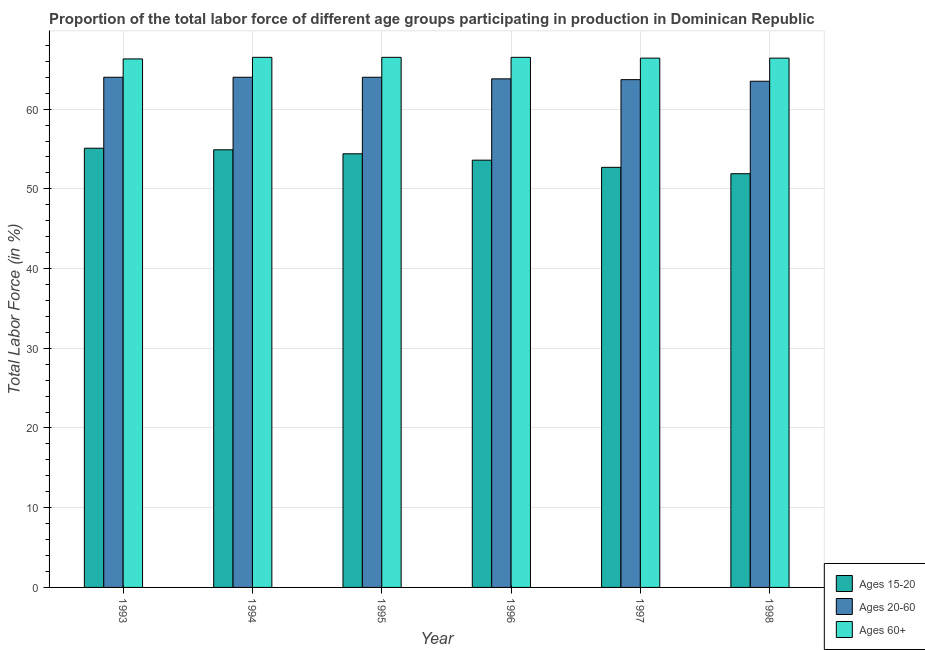How many different coloured bars are there?
Provide a succinct answer. 3. Are the number of bars on each tick of the X-axis equal?
Your response must be concise. Yes. How many bars are there on the 4th tick from the left?
Keep it short and to the point. 3. How many bars are there on the 6th tick from the right?
Make the answer very short. 3. In how many cases, is the number of bars for a given year not equal to the number of legend labels?
Provide a short and direct response. 0. What is the percentage of labor force above age 60 in 1996?
Your answer should be very brief. 66.5. Across all years, what is the maximum percentage of labor force within the age group 20-60?
Your answer should be compact. 64. Across all years, what is the minimum percentage of labor force within the age group 20-60?
Your response must be concise. 63.5. In which year was the percentage of labor force above age 60 maximum?
Your response must be concise. 1994. In which year was the percentage of labor force within the age group 20-60 minimum?
Make the answer very short. 1998. What is the total percentage of labor force within the age group 20-60 in the graph?
Make the answer very short. 383. What is the difference between the percentage of labor force within the age group 15-20 in 1995 and that in 1996?
Your answer should be compact. 0.8. What is the difference between the percentage of labor force within the age group 20-60 in 1998 and the percentage of labor force above age 60 in 1994?
Offer a very short reply. -0.5. What is the average percentage of labor force above age 60 per year?
Your answer should be compact. 66.43. In the year 1996, what is the difference between the percentage of labor force within the age group 15-20 and percentage of labor force above age 60?
Your answer should be very brief. 0. What is the ratio of the percentage of labor force above age 60 in 1994 to that in 1998?
Provide a succinct answer. 1. Is the percentage of labor force within the age group 20-60 in 1996 less than that in 1998?
Offer a terse response. No. What is the difference between the highest and the second highest percentage of labor force within the age group 20-60?
Ensure brevity in your answer.  0. What does the 1st bar from the left in 1994 represents?
Provide a succinct answer. Ages 15-20. What does the 3rd bar from the right in 1994 represents?
Ensure brevity in your answer.  Ages 15-20. Is it the case that in every year, the sum of the percentage of labor force within the age group 15-20 and percentage of labor force within the age group 20-60 is greater than the percentage of labor force above age 60?
Make the answer very short. Yes. Are all the bars in the graph horizontal?
Make the answer very short. No. What is the difference between two consecutive major ticks on the Y-axis?
Offer a terse response. 10. Are the values on the major ticks of Y-axis written in scientific E-notation?
Give a very brief answer. No. Does the graph contain any zero values?
Provide a short and direct response. No. How are the legend labels stacked?
Provide a succinct answer. Vertical. What is the title of the graph?
Provide a short and direct response. Proportion of the total labor force of different age groups participating in production in Dominican Republic. Does "Tertiary education" appear as one of the legend labels in the graph?
Provide a short and direct response. No. What is the Total Labor Force (in %) of Ages 15-20 in 1993?
Your response must be concise. 55.1. What is the Total Labor Force (in %) of Ages 60+ in 1993?
Your answer should be very brief. 66.3. What is the Total Labor Force (in %) in Ages 15-20 in 1994?
Offer a terse response. 54.9. What is the Total Labor Force (in %) in Ages 60+ in 1994?
Your response must be concise. 66.5. What is the Total Labor Force (in %) in Ages 15-20 in 1995?
Your response must be concise. 54.4. What is the Total Labor Force (in %) of Ages 60+ in 1995?
Your answer should be compact. 66.5. What is the Total Labor Force (in %) of Ages 15-20 in 1996?
Give a very brief answer. 53.6. What is the Total Labor Force (in %) of Ages 20-60 in 1996?
Give a very brief answer. 63.8. What is the Total Labor Force (in %) in Ages 60+ in 1996?
Your response must be concise. 66.5. What is the Total Labor Force (in %) in Ages 15-20 in 1997?
Ensure brevity in your answer.  52.7. What is the Total Labor Force (in %) in Ages 20-60 in 1997?
Your response must be concise. 63.7. What is the Total Labor Force (in %) of Ages 60+ in 1997?
Give a very brief answer. 66.4. What is the Total Labor Force (in %) of Ages 15-20 in 1998?
Give a very brief answer. 51.9. What is the Total Labor Force (in %) in Ages 20-60 in 1998?
Your answer should be compact. 63.5. What is the Total Labor Force (in %) in Ages 60+ in 1998?
Offer a very short reply. 66.4. Across all years, what is the maximum Total Labor Force (in %) of Ages 15-20?
Ensure brevity in your answer.  55.1. Across all years, what is the maximum Total Labor Force (in %) in Ages 20-60?
Provide a succinct answer. 64. Across all years, what is the maximum Total Labor Force (in %) of Ages 60+?
Offer a terse response. 66.5. Across all years, what is the minimum Total Labor Force (in %) in Ages 15-20?
Provide a succinct answer. 51.9. Across all years, what is the minimum Total Labor Force (in %) in Ages 20-60?
Provide a short and direct response. 63.5. Across all years, what is the minimum Total Labor Force (in %) of Ages 60+?
Provide a succinct answer. 66.3. What is the total Total Labor Force (in %) of Ages 15-20 in the graph?
Offer a very short reply. 322.6. What is the total Total Labor Force (in %) of Ages 20-60 in the graph?
Make the answer very short. 383. What is the total Total Labor Force (in %) of Ages 60+ in the graph?
Offer a very short reply. 398.6. What is the difference between the Total Labor Force (in %) of Ages 20-60 in 1993 and that in 1994?
Your response must be concise. 0. What is the difference between the Total Labor Force (in %) of Ages 15-20 in 1993 and that in 1995?
Your answer should be compact. 0.7. What is the difference between the Total Labor Force (in %) in Ages 20-60 in 1993 and that in 1995?
Your answer should be very brief. 0. What is the difference between the Total Labor Force (in %) of Ages 20-60 in 1993 and that in 1996?
Offer a very short reply. 0.2. What is the difference between the Total Labor Force (in %) in Ages 15-20 in 1993 and that in 1997?
Give a very brief answer. 2.4. What is the difference between the Total Labor Force (in %) in Ages 60+ in 1993 and that in 1997?
Keep it short and to the point. -0.1. What is the difference between the Total Labor Force (in %) in Ages 60+ in 1993 and that in 1998?
Give a very brief answer. -0.1. What is the difference between the Total Labor Force (in %) in Ages 15-20 in 1994 and that in 1995?
Your response must be concise. 0.5. What is the difference between the Total Labor Force (in %) of Ages 60+ in 1994 and that in 1995?
Provide a short and direct response. 0. What is the difference between the Total Labor Force (in %) of Ages 15-20 in 1994 and that in 1996?
Offer a very short reply. 1.3. What is the difference between the Total Labor Force (in %) in Ages 15-20 in 1994 and that in 1998?
Your answer should be very brief. 3. What is the difference between the Total Labor Force (in %) of Ages 15-20 in 1995 and that in 1996?
Your response must be concise. 0.8. What is the difference between the Total Labor Force (in %) of Ages 20-60 in 1995 and that in 1996?
Give a very brief answer. 0.2. What is the difference between the Total Labor Force (in %) in Ages 15-20 in 1995 and that in 1997?
Offer a terse response. 1.7. What is the difference between the Total Labor Force (in %) in Ages 20-60 in 1995 and that in 1997?
Provide a succinct answer. 0.3. What is the difference between the Total Labor Force (in %) in Ages 60+ in 1995 and that in 1997?
Keep it short and to the point. 0.1. What is the difference between the Total Labor Force (in %) of Ages 15-20 in 1995 and that in 1998?
Offer a terse response. 2.5. What is the difference between the Total Labor Force (in %) in Ages 60+ in 1995 and that in 1998?
Ensure brevity in your answer.  0.1. What is the difference between the Total Labor Force (in %) of Ages 20-60 in 1996 and that in 1997?
Provide a short and direct response. 0.1. What is the difference between the Total Labor Force (in %) of Ages 15-20 in 1996 and that in 1998?
Ensure brevity in your answer.  1.7. What is the difference between the Total Labor Force (in %) in Ages 20-60 in 1996 and that in 1998?
Provide a short and direct response. 0.3. What is the difference between the Total Labor Force (in %) of Ages 60+ in 1996 and that in 1998?
Keep it short and to the point. 0.1. What is the difference between the Total Labor Force (in %) of Ages 15-20 in 1997 and that in 1998?
Keep it short and to the point. 0.8. What is the difference between the Total Labor Force (in %) of Ages 20-60 in 1997 and that in 1998?
Ensure brevity in your answer.  0.2. What is the difference between the Total Labor Force (in %) in Ages 60+ in 1997 and that in 1998?
Your answer should be very brief. 0. What is the difference between the Total Labor Force (in %) in Ages 20-60 in 1993 and the Total Labor Force (in %) in Ages 60+ in 1994?
Keep it short and to the point. -2.5. What is the difference between the Total Labor Force (in %) in Ages 15-20 in 1993 and the Total Labor Force (in %) in Ages 20-60 in 1995?
Keep it short and to the point. -8.9. What is the difference between the Total Labor Force (in %) in Ages 15-20 in 1993 and the Total Labor Force (in %) in Ages 20-60 in 1997?
Make the answer very short. -8.6. What is the difference between the Total Labor Force (in %) in Ages 15-20 in 1993 and the Total Labor Force (in %) in Ages 60+ in 1997?
Give a very brief answer. -11.3. What is the difference between the Total Labor Force (in %) in Ages 15-20 in 1993 and the Total Labor Force (in %) in Ages 20-60 in 1998?
Provide a succinct answer. -8.4. What is the difference between the Total Labor Force (in %) in Ages 15-20 in 1994 and the Total Labor Force (in %) in Ages 20-60 in 1995?
Ensure brevity in your answer.  -9.1. What is the difference between the Total Labor Force (in %) in Ages 15-20 in 1994 and the Total Labor Force (in %) in Ages 60+ in 1995?
Your response must be concise. -11.6. What is the difference between the Total Labor Force (in %) of Ages 15-20 in 1994 and the Total Labor Force (in %) of Ages 20-60 in 1996?
Ensure brevity in your answer.  -8.9. What is the difference between the Total Labor Force (in %) in Ages 20-60 in 1994 and the Total Labor Force (in %) in Ages 60+ in 1997?
Offer a terse response. -2.4. What is the difference between the Total Labor Force (in %) of Ages 15-20 in 1994 and the Total Labor Force (in %) of Ages 60+ in 1998?
Provide a short and direct response. -11.5. What is the difference between the Total Labor Force (in %) of Ages 20-60 in 1994 and the Total Labor Force (in %) of Ages 60+ in 1998?
Make the answer very short. -2.4. What is the difference between the Total Labor Force (in %) in Ages 20-60 in 1995 and the Total Labor Force (in %) in Ages 60+ in 1996?
Make the answer very short. -2.5. What is the difference between the Total Labor Force (in %) of Ages 15-20 in 1995 and the Total Labor Force (in %) of Ages 60+ in 1997?
Keep it short and to the point. -12. What is the difference between the Total Labor Force (in %) in Ages 20-60 in 1995 and the Total Labor Force (in %) in Ages 60+ in 1997?
Ensure brevity in your answer.  -2.4. What is the difference between the Total Labor Force (in %) of Ages 15-20 in 1995 and the Total Labor Force (in %) of Ages 60+ in 1998?
Give a very brief answer. -12. What is the difference between the Total Labor Force (in %) of Ages 20-60 in 1995 and the Total Labor Force (in %) of Ages 60+ in 1998?
Your answer should be compact. -2.4. What is the difference between the Total Labor Force (in %) in Ages 15-20 in 1996 and the Total Labor Force (in %) in Ages 60+ in 1997?
Keep it short and to the point. -12.8. What is the difference between the Total Labor Force (in %) in Ages 20-60 in 1996 and the Total Labor Force (in %) in Ages 60+ in 1998?
Provide a short and direct response. -2.6. What is the difference between the Total Labor Force (in %) in Ages 15-20 in 1997 and the Total Labor Force (in %) in Ages 60+ in 1998?
Offer a terse response. -13.7. What is the difference between the Total Labor Force (in %) of Ages 20-60 in 1997 and the Total Labor Force (in %) of Ages 60+ in 1998?
Offer a terse response. -2.7. What is the average Total Labor Force (in %) of Ages 15-20 per year?
Offer a very short reply. 53.77. What is the average Total Labor Force (in %) of Ages 20-60 per year?
Offer a terse response. 63.83. What is the average Total Labor Force (in %) of Ages 60+ per year?
Your answer should be very brief. 66.43. In the year 1993, what is the difference between the Total Labor Force (in %) in Ages 15-20 and Total Labor Force (in %) in Ages 20-60?
Ensure brevity in your answer.  -8.9. In the year 1993, what is the difference between the Total Labor Force (in %) in Ages 15-20 and Total Labor Force (in %) in Ages 60+?
Your answer should be compact. -11.2. In the year 1993, what is the difference between the Total Labor Force (in %) in Ages 20-60 and Total Labor Force (in %) in Ages 60+?
Your response must be concise. -2.3. In the year 1994, what is the difference between the Total Labor Force (in %) in Ages 15-20 and Total Labor Force (in %) in Ages 20-60?
Keep it short and to the point. -9.1. In the year 1994, what is the difference between the Total Labor Force (in %) of Ages 15-20 and Total Labor Force (in %) of Ages 60+?
Ensure brevity in your answer.  -11.6. In the year 1994, what is the difference between the Total Labor Force (in %) of Ages 20-60 and Total Labor Force (in %) of Ages 60+?
Provide a short and direct response. -2.5. In the year 1995, what is the difference between the Total Labor Force (in %) in Ages 15-20 and Total Labor Force (in %) in Ages 60+?
Your response must be concise. -12.1. In the year 1996, what is the difference between the Total Labor Force (in %) in Ages 20-60 and Total Labor Force (in %) in Ages 60+?
Make the answer very short. -2.7. In the year 1997, what is the difference between the Total Labor Force (in %) of Ages 15-20 and Total Labor Force (in %) of Ages 60+?
Give a very brief answer. -13.7. In the year 1997, what is the difference between the Total Labor Force (in %) in Ages 20-60 and Total Labor Force (in %) in Ages 60+?
Your answer should be very brief. -2.7. In the year 1998, what is the difference between the Total Labor Force (in %) in Ages 15-20 and Total Labor Force (in %) in Ages 20-60?
Your response must be concise. -11.6. In the year 1998, what is the difference between the Total Labor Force (in %) in Ages 15-20 and Total Labor Force (in %) in Ages 60+?
Your answer should be compact. -14.5. In the year 1998, what is the difference between the Total Labor Force (in %) in Ages 20-60 and Total Labor Force (in %) in Ages 60+?
Give a very brief answer. -2.9. What is the ratio of the Total Labor Force (in %) in Ages 15-20 in 1993 to that in 1994?
Offer a very short reply. 1. What is the ratio of the Total Labor Force (in %) of Ages 20-60 in 1993 to that in 1994?
Your answer should be very brief. 1. What is the ratio of the Total Labor Force (in %) in Ages 60+ in 1993 to that in 1994?
Offer a terse response. 1. What is the ratio of the Total Labor Force (in %) in Ages 15-20 in 1993 to that in 1995?
Give a very brief answer. 1.01. What is the ratio of the Total Labor Force (in %) of Ages 20-60 in 1993 to that in 1995?
Ensure brevity in your answer.  1. What is the ratio of the Total Labor Force (in %) of Ages 15-20 in 1993 to that in 1996?
Your answer should be compact. 1.03. What is the ratio of the Total Labor Force (in %) in Ages 20-60 in 1993 to that in 1996?
Provide a short and direct response. 1. What is the ratio of the Total Labor Force (in %) of Ages 60+ in 1993 to that in 1996?
Your answer should be very brief. 1. What is the ratio of the Total Labor Force (in %) in Ages 15-20 in 1993 to that in 1997?
Give a very brief answer. 1.05. What is the ratio of the Total Labor Force (in %) of Ages 20-60 in 1993 to that in 1997?
Your answer should be compact. 1. What is the ratio of the Total Labor Force (in %) of Ages 15-20 in 1993 to that in 1998?
Your answer should be very brief. 1.06. What is the ratio of the Total Labor Force (in %) in Ages 20-60 in 1993 to that in 1998?
Provide a short and direct response. 1.01. What is the ratio of the Total Labor Force (in %) of Ages 15-20 in 1994 to that in 1995?
Keep it short and to the point. 1.01. What is the ratio of the Total Labor Force (in %) in Ages 15-20 in 1994 to that in 1996?
Make the answer very short. 1.02. What is the ratio of the Total Labor Force (in %) in Ages 60+ in 1994 to that in 1996?
Keep it short and to the point. 1. What is the ratio of the Total Labor Force (in %) in Ages 15-20 in 1994 to that in 1997?
Keep it short and to the point. 1.04. What is the ratio of the Total Labor Force (in %) in Ages 20-60 in 1994 to that in 1997?
Give a very brief answer. 1. What is the ratio of the Total Labor Force (in %) in Ages 15-20 in 1994 to that in 1998?
Give a very brief answer. 1.06. What is the ratio of the Total Labor Force (in %) in Ages 20-60 in 1994 to that in 1998?
Your response must be concise. 1.01. What is the ratio of the Total Labor Force (in %) of Ages 60+ in 1994 to that in 1998?
Offer a very short reply. 1. What is the ratio of the Total Labor Force (in %) of Ages 15-20 in 1995 to that in 1996?
Offer a terse response. 1.01. What is the ratio of the Total Labor Force (in %) of Ages 20-60 in 1995 to that in 1996?
Make the answer very short. 1. What is the ratio of the Total Labor Force (in %) of Ages 60+ in 1995 to that in 1996?
Make the answer very short. 1. What is the ratio of the Total Labor Force (in %) in Ages 15-20 in 1995 to that in 1997?
Give a very brief answer. 1.03. What is the ratio of the Total Labor Force (in %) in Ages 60+ in 1995 to that in 1997?
Make the answer very short. 1. What is the ratio of the Total Labor Force (in %) of Ages 15-20 in 1995 to that in 1998?
Provide a short and direct response. 1.05. What is the ratio of the Total Labor Force (in %) in Ages 20-60 in 1995 to that in 1998?
Ensure brevity in your answer.  1.01. What is the ratio of the Total Labor Force (in %) of Ages 60+ in 1995 to that in 1998?
Offer a very short reply. 1. What is the ratio of the Total Labor Force (in %) in Ages 15-20 in 1996 to that in 1997?
Provide a succinct answer. 1.02. What is the ratio of the Total Labor Force (in %) of Ages 20-60 in 1996 to that in 1997?
Provide a succinct answer. 1. What is the ratio of the Total Labor Force (in %) in Ages 15-20 in 1996 to that in 1998?
Keep it short and to the point. 1.03. What is the ratio of the Total Labor Force (in %) of Ages 15-20 in 1997 to that in 1998?
Give a very brief answer. 1.02. What is the ratio of the Total Labor Force (in %) of Ages 20-60 in 1997 to that in 1998?
Your answer should be very brief. 1. What is the ratio of the Total Labor Force (in %) of Ages 60+ in 1997 to that in 1998?
Give a very brief answer. 1. What is the difference between the highest and the second highest Total Labor Force (in %) in Ages 20-60?
Your answer should be compact. 0. What is the difference between the highest and the second highest Total Labor Force (in %) in Ages 60+?
Your answer should be compact. 0. What is the difference between the highest and the lowest Total Labor Force (in %) of Ages 60+?
Your answer should be very brief. 0.2. 